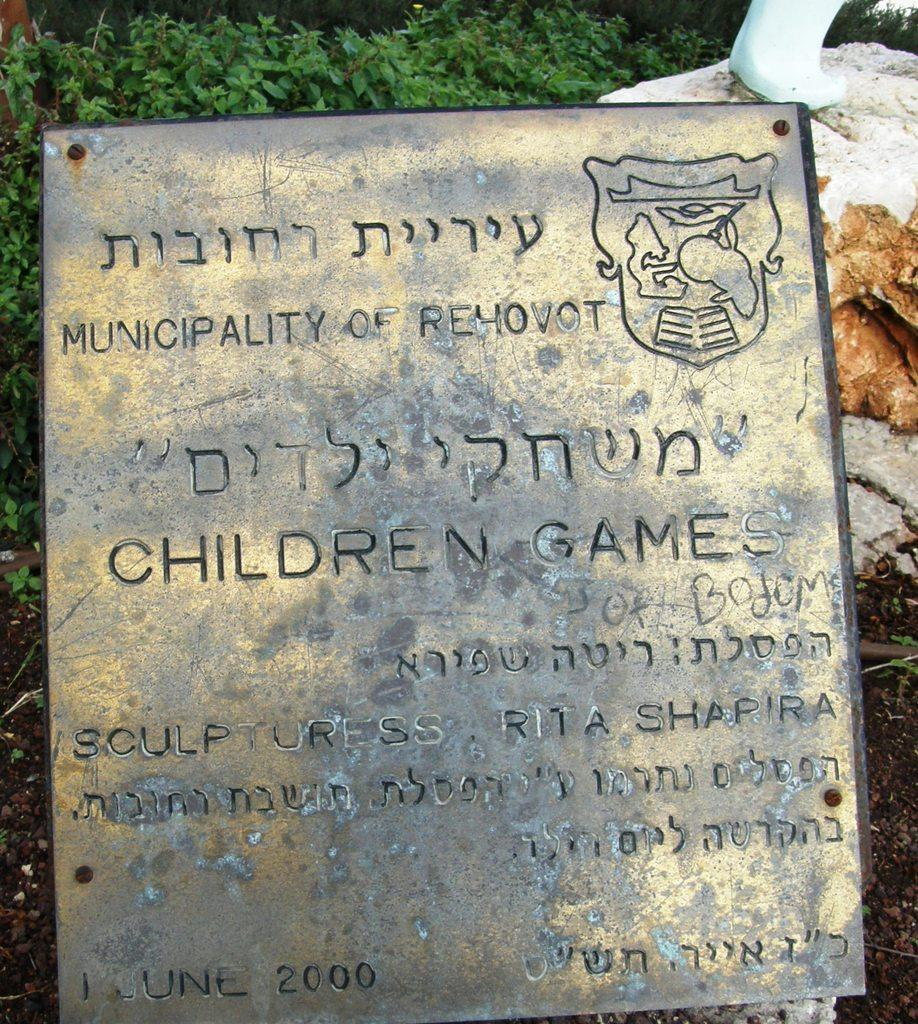What is the main structure visible in the image? There is a metal frame in the image. What is written on the metal frame? There is writing on the metal frame. What can be seen in the background of the image? There are plants in the background of the image. What type of natural elements are present on the right side of the image? There are rocks on the right side of the image. Can you tell me how many facts are visible on the ground in the image? There are no facts visible on the ground in the image; the facts provided are about the metal frame, plants, and rocks. Is there a skateboard visible in the image? There is no skateboard present in the image. 